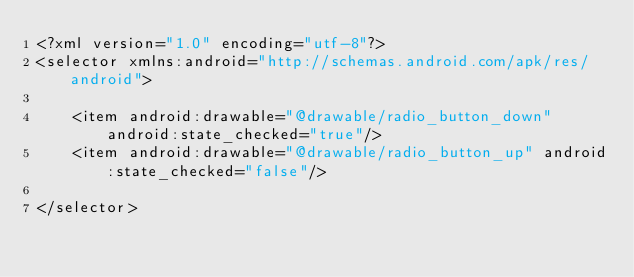Convert code to text. <code><loc_0><loc_0><loc_500><loc_500><_XML_><?xml version="1.0" encoding="utf-8"?>
<selector xmlns:android="http://schemas.android.com/apk/res/android">

    <item android:drawable="@drawable/radio_button_down" android:state_checked="true"/>
    <item android:drawable="@drawable/radio_button_up" android:state_checked="false"/>

</selector></code> 